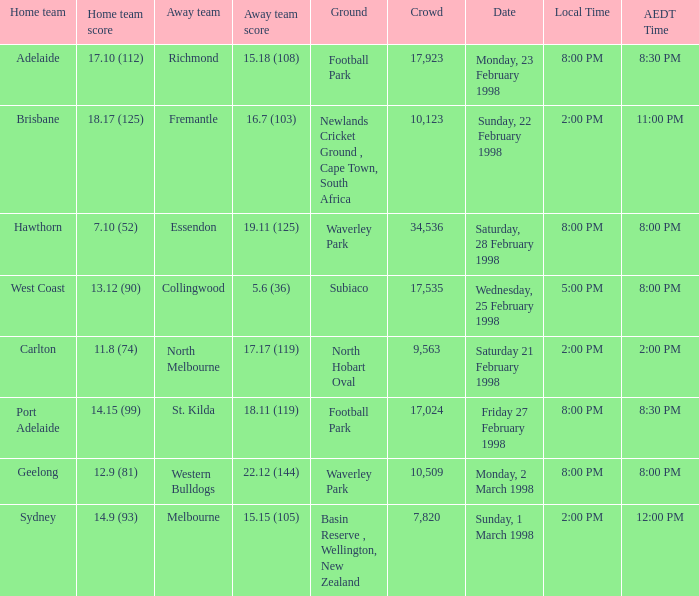Which Home team is on Wednesday, 25 february 1998? West Coast. 